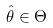<formula> <loc_0><loc_0><loc_500><loc_500>\hat { \theta } \in \Theta</formula> 